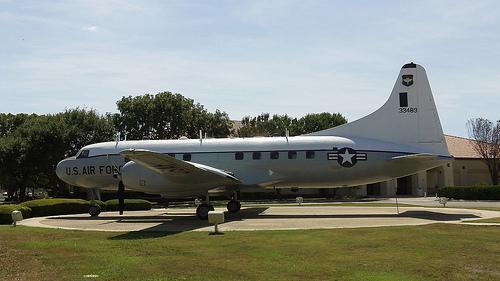How many planes are there?
Give a very brief answer. 1. 